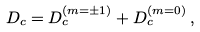<formula> <loc_0><loc_0><loc_500><loc_500>D _ { c } = D _ { c } ^ { ( m = \pm 1 ) } + D _ { c } ^ { ( m = 0 ) } \, ,</formula> 